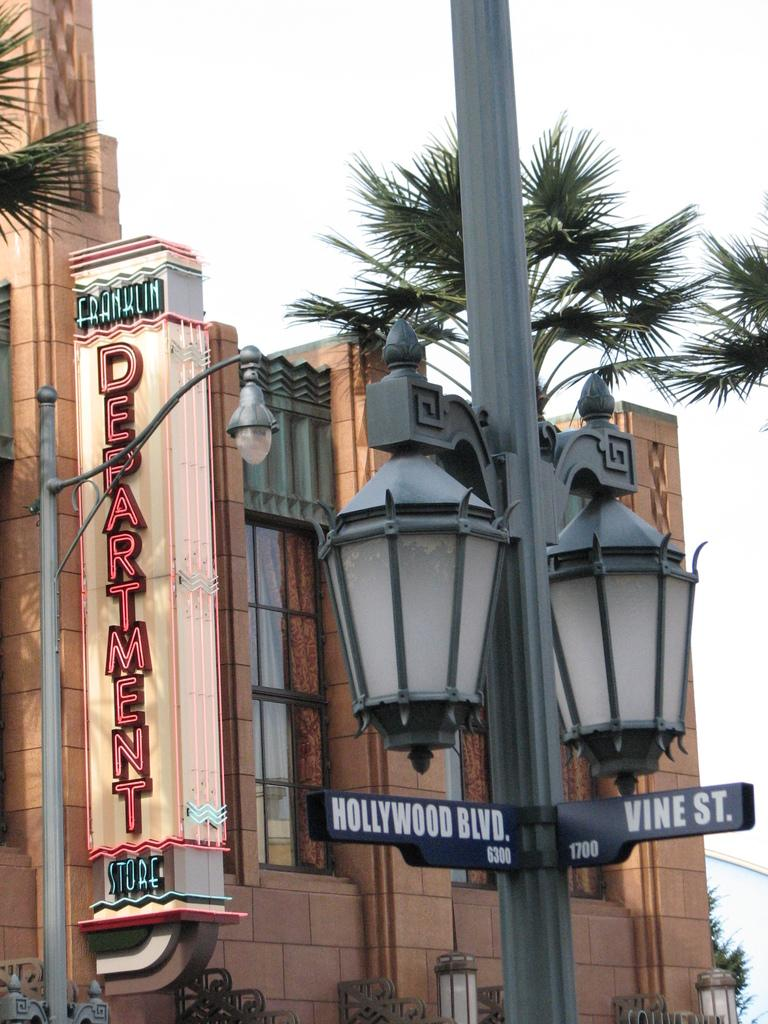<image>
Render a clear and concise summary of the photo. A lamp post show the street names of Hollywood Blvd. and Vine St. 